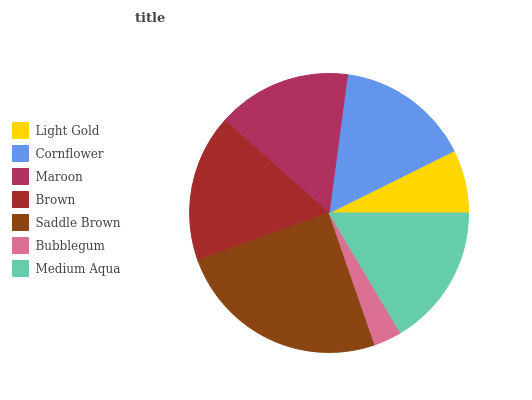Is Bubblegum the minimum?
Answer yes or no. Yes. Is Saddle Brown the maximum?
Answer yes or no. Yes. Is Cornflower the minimum?
Answer yes or no. No. Is Cornflower the maximum?
Answer yes or no. No. Is Cornflower greater than Light Gold?
Answer yes or no. Yes. Is Light Gold less than Cornflower?
Answer yes or no. Yes. Is Light Gold greater than Cornflower?
Answer yes or no. No. Is Cornflower less than Light Gold?
Answer yes or no. No. Is Cornflower the high median?
Answer yes or no. Yes. Is Cornflower the low median?
Answer yes or no. Yes. Is Saddle Brown the high median?
Answer yes or no. No. Is Medium Aqua the low median?
Answer yes or no. No. 